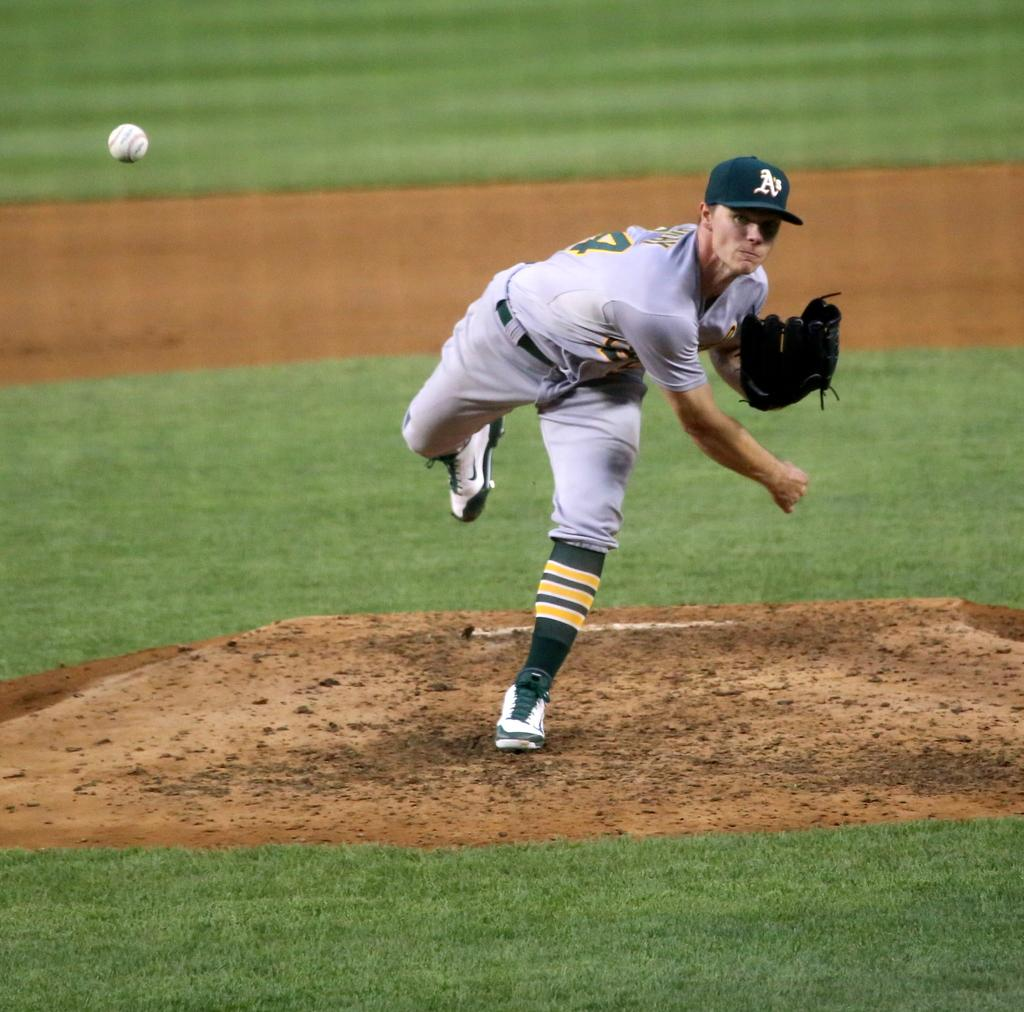<image>
Give a short and clear explanation of the subsequent image. a man with an A's hat om his head on the mound 